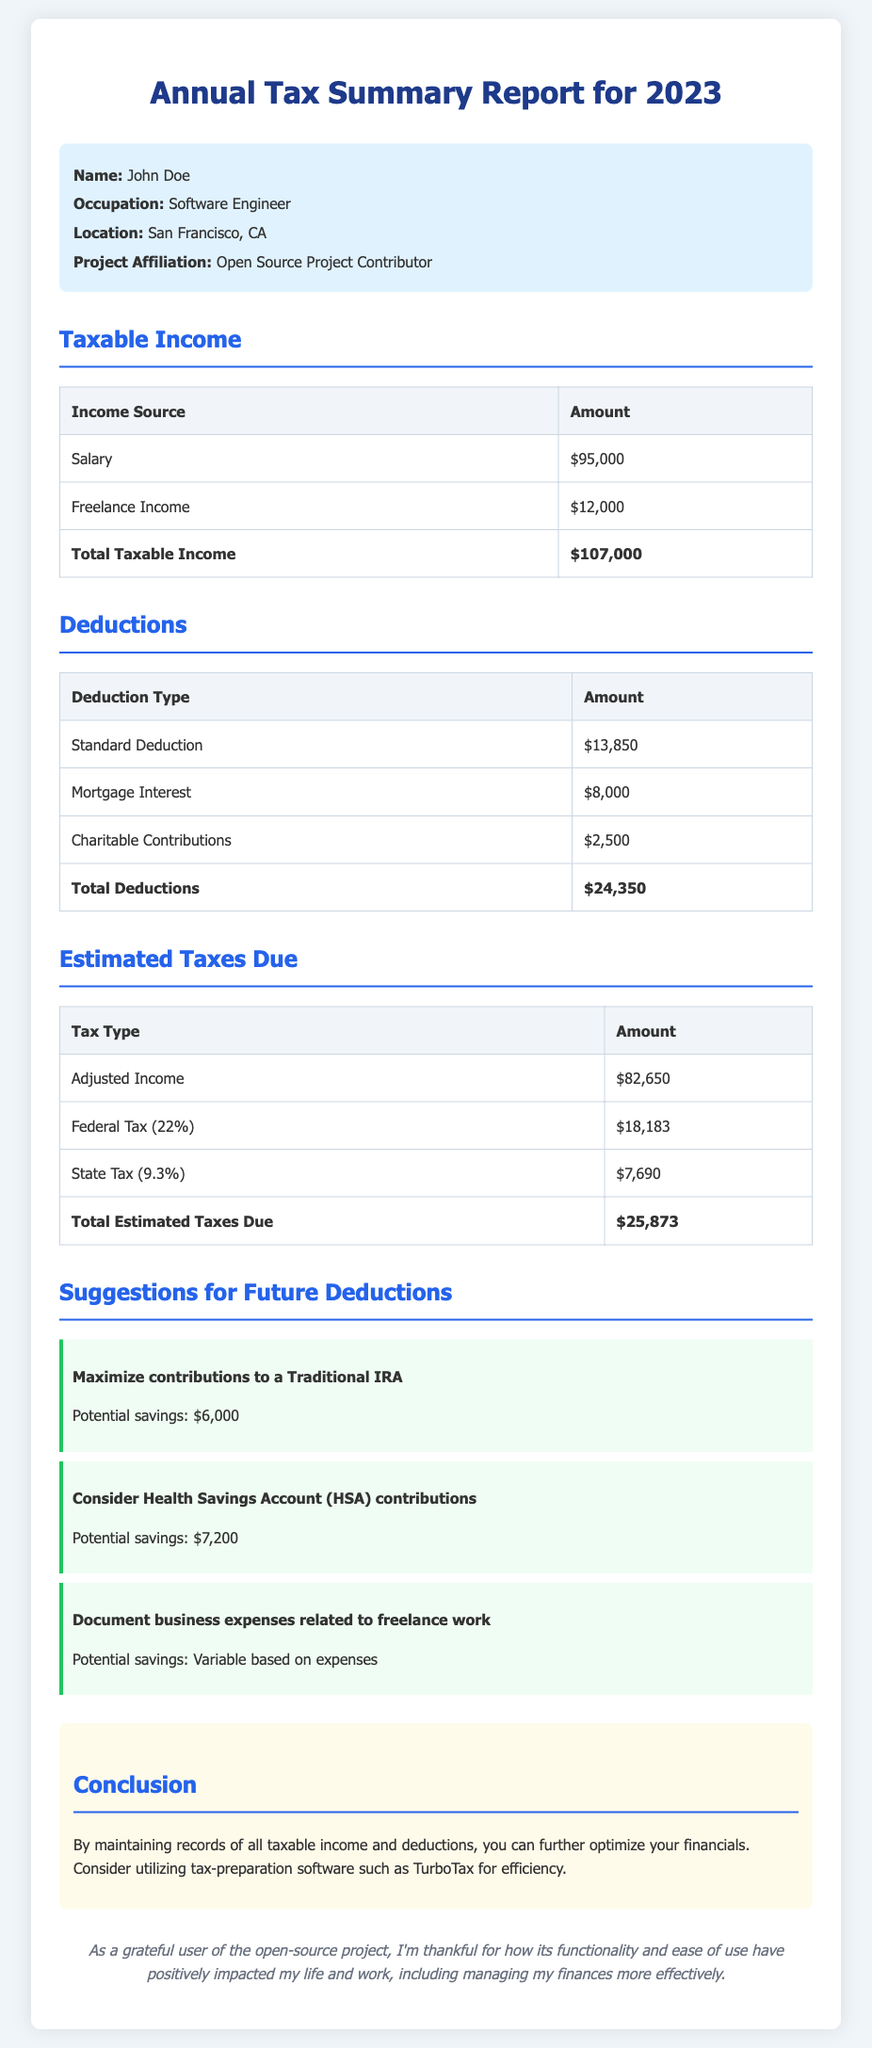What is the total taxable income? The total taxable income is presented in the document as the sum of Salary and Freelance Income, which is $95,000 + $12,000.
Answer: $107,000 What is the amount for mortgage interest deduction? The document lists mortgage interest as one of the deductions, which is specified as $8,000.
Answer: $8,000 What is the total estimated taxes due? The total estimated taxes due is the sum presented at the end of the tax calculations, which equals $25,873.
Answer: $25,873 Which city is the user located in? The document specifies the user's location as San Francisco, CA.
Answer: San Francisco, CA How much can be saved by maximizing contributions to a Traditional IRA? The document suggests potential savings of $6,000 by maximizing contributions to a Traditional IRA.
Answer: $6,000 What percentage is listed for Federal Tax? The Federal Tax percentage mentioned in the document is 22%.
Answer: 22% What is one suggestion for future deductions related to health? The document recommends considering Health Savings Account (HSA) contributions as a future deduction.
Answer: Health Savings Account (HSA) contributions What is the total amount of deductions? The total amount of deductions is calculated and presented in the document as $24,350.
Answer: $24,350 What is the name of the user in the report? The user's name is prominently displayed at the beginning of the report as John Doe.
Answer: John Doe 